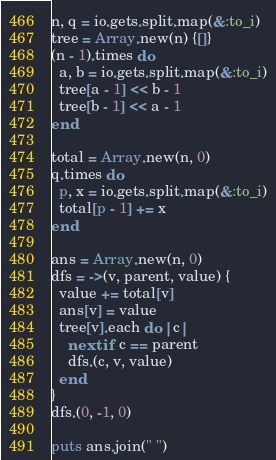Convert code to text. <code><loc_0><loc_0><loc_500><loc_500><_Ruby_>n, q = io.gets.split.map(&:to_i)
tree = Array.new(n) {[]}
(n - 1).times do
  a, b = io.gets.split.map(&:to_i)
  tree[a - 1] << b - 1
  tree[b - 1] << a - 1
end

total = Array.new(n, 0)
q.times do
  p, x = io.gets.split.map(&:to_i)
  total[p - 1] += x
end

ans = Array.new(n, 0)
dfs = ->(v, parent, value) {
  value += total[v]
  ans[v] = value
  tree[v].each do |c|
    next if c == parent
    dfs.(c, v, value)
  end
}
dfs.(0, -1, 0)

puts ans.join(" ")
</code> 